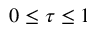Convert formula to latex. <formula><loc_0><loc_0><loc_500><loc_500>0 \leq \tau \leq 1</formula> 